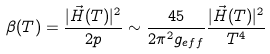<formula> <loc_0><loc_0><loc_500><loc_500>\beta ( T ) = \frac { | \vec { H } ( T ) | ^ { 2 } } { 2 p } \sim \frac { 4 5 } { 2 \pi ^ { 2 } g _ { e f f } } \frac { | \vec { H } ( T ) | ^ { 2 } } { T ^ { 4 } }</formula> 